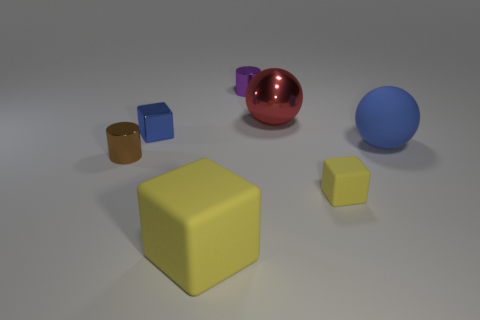If the objects in this image represented a family, what roles might they play? If we were to personify the objects as a family, the large yellow cube could represent a guardian or parent figure due to its size and central role. The smaller yellow cube might be seen as a child or younger sibling. The blue sphere could be an older sibling, with its calm color and substantial size, while the shiny object, due to its reflective quality, could be seen as a charismatic family member. The brown cylinder might represent a steadfast, reliable member, possibly an uncle or grandparent, with its solid, unadorned appearance. 